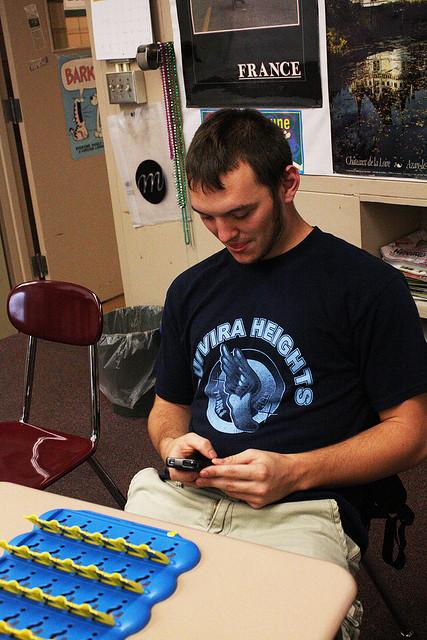What game is he playing?
Be succinct. Guess who. Does the man appear to be happy?
Concise answer only. Yes. Is the item on the table a toy?
Be succinct. Yes. Does this man have a beard?
Write a very short answer. Yes. 